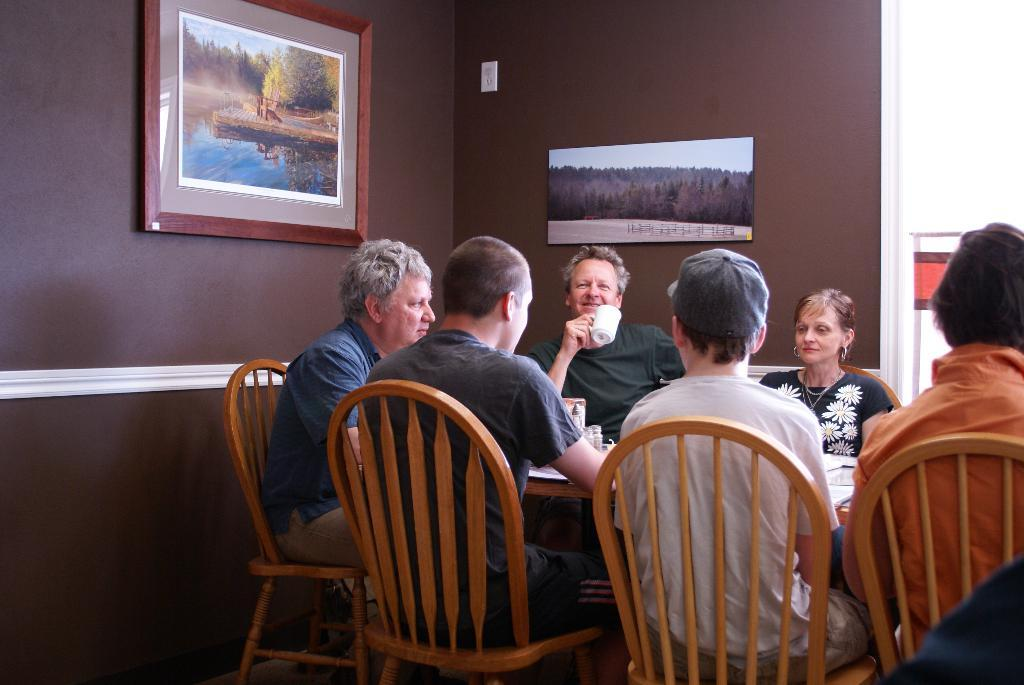What is the main subject of the image? The main subject of the image is a group of people. What are the people doing in the image? The people are sitting in chairs in the image. How are the chairs arranged in the image? The chairs are arranged around a table in the image. What can be seen on the walls in the image? There are photographic frames on the walls in the image. What type of blade is being used by the people in the image? There is no blade present in the image; the people are sitting in chairs around a table. 